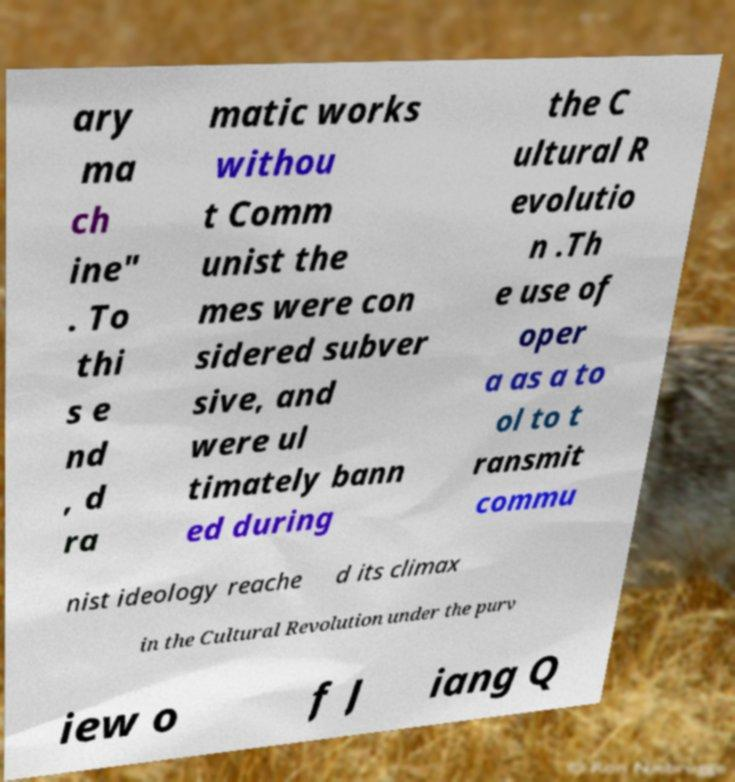Can you accurately transcribe the text from the provided image for me? ary ma ch ine" . To thi s e nd , d ra matic works withou t Comm unist the mes were con sidered subver sive, and were ul timately bann ed during the C ultural R evolutio n .Th e use of oper a as a to ol to t ransmit commu nist ideology reache d its climax in the Cultural Revolution under the purv iew o f J iang Q 